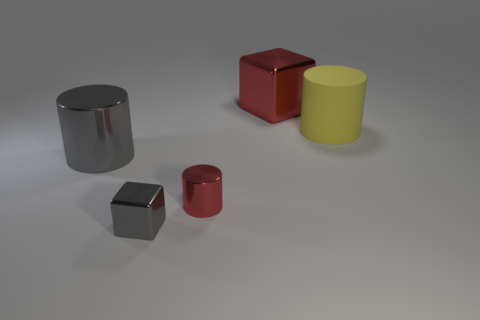Is there any other thing that has the same material as the large gray thing?
Give a very brief answer. Yes. Are there more tiny gray shiny objects than small brown cylinders?
Make the answer very short. Yes. What shape is the large shiny object right of the gray metal object that is in front of the large cylinder on the left side of the red metallic cylinder?
Your answer should be very brief. Cube. Does the cylinder right of the large red metal object have the same material as the gray thing on the left side of the tiny cube?
Provide a succinct answer. No. What shape is the other large object that is made of the same material as the big red thing?
Make the answer very short. Cylinder. Is there anything else that has the same color as the big metallic cylinder?
Keep it short and to the point. Yes. How many large things are there?
Keep it short and to the point. 3. There is a small cylinder in front of the object behind the yellow cylinder; what is its material?
Ensure brevity in your answer.  Metal. What color is the small thing that is behind the gray metal thing to the right of the large metallic cylinder that is on the left side of the large red metallic object?
Offer a very short reply. Red. Is the color of the large block the same as the tiny block?
Your response must be concise. No. 